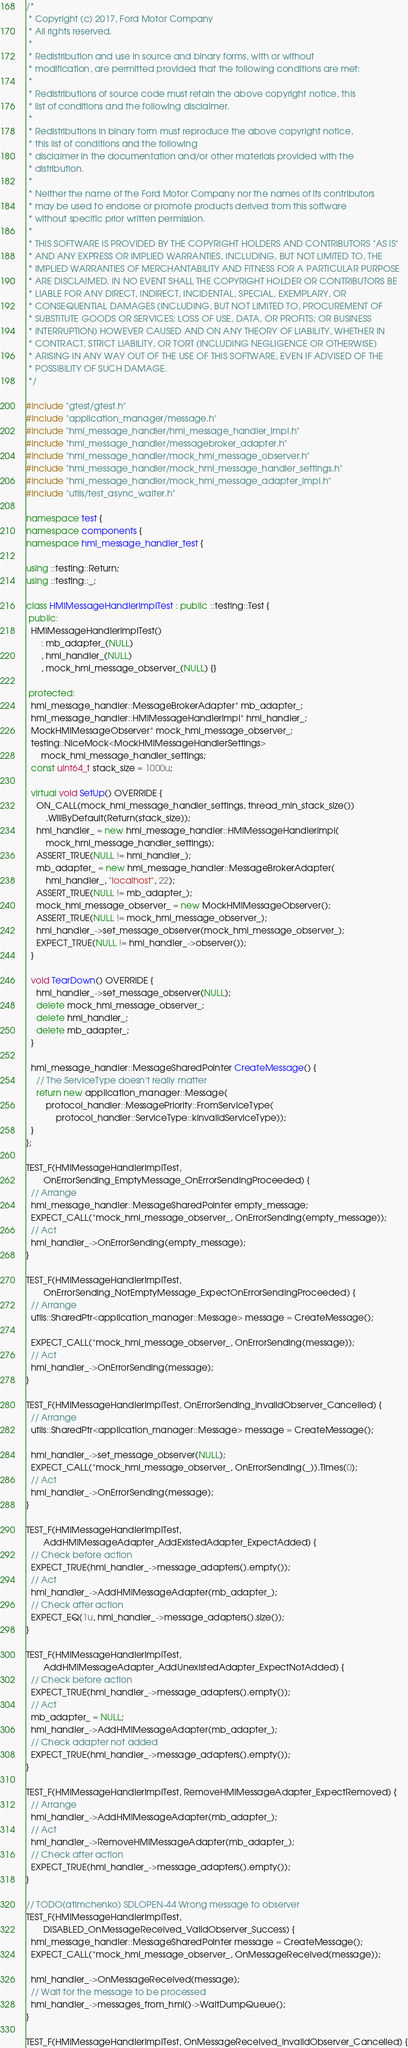Convert code to text. <code><loc_0><loc_0><loc_500><loc_500><_C++_>/*
 * Copyright (c) 2017, Ford Motor Company
 * All rights reserved.
 *
 * Redistribution and use in source and binary forms, with or without
 * modification, are permitted provided that the following conditions are met:
 *
 * Redistributions of source code must retain the above copyright notice, this
 * list of conditions and the following disclaimer.
 *
 * Redistributions in binary form must reproduce the above copyright notice,
 * this list of conditions and the following
 * disclaimer in the documentation and/or other materials provided with the
 * distribution.
 *
 * Neither the name of the Ford Motor Company nor the names of its contributors
 * may be used to endorse or promote products derived from this software
 * without specific prior written permission.
 *
 * THIS SOFTWARE IS PROVIDED BY THE COPYRIGHT HOLDERS AND CONTRIBUTORS "AS IS"
 * AND ANY EXPRESS OR IMPLIED WARRANTIES, INCLUDING, BUT NOT LIMITED TO, THE
 * IMPLIED WARRANTIES OF MERCHANTABILITY AND FITNESS FOR A PARTICULAR PURPOSE
 * ARE DISCLAIMED. IN NO EVENT SHALL THE COPYRIGHT HOLDER OR CONTRIBUTORS BE
 * LIABLE FOR ANY DIRECT, INDIRECT, INCIDENTAL, SPECIAL, EXEMPLARY, OR
 * CONSEQUENTIAL DAMAGES (INCLUDING, BUT NOT LIMITED TO, PROCUREMENT OF
 * SUBSTITUTE GOODS OR SERVICES; LOSS OF USE, DATA, OR PROFITS; OR BUSINESS
 * INTERRUPTION) HOWEVER CAUSED AND ON ANY THEORY OF LIABILITY, WHETHER IN
 * CONTRACT, STRICT LIABILITY, OR TORT (INCLUDING NEGLIGENCE OR OTHERWISE)
 * ARISING IN ANY WAY OUT OF THE USE OF THIS SOFTWARE, EVEN IF ADVISED OF THE
 * POSSIBILITY OF SUCH DAMAGE.
 */

#include "gtest/gtest.h"
#include "application_manager/message.h"
#include "hmi_message_handler/hmi_message_handler_impl.h"
#include "hmi_message_handler/messagebroker_adapter.h"
#include "hmi_message_handler/mock_hmi_message_observer.h"
#include "hmi_message_handler/mock_hmi_message_handler_settings.h"
#include "hmi_message_handler/mock_hmi_message_adapter_impl.h"
#include "utils/test_async_waiter.h"

namespace test {
namespace components {
namespace hmi_message_handler_test {

using ::testing::Return;
using ::testing::_;

class HMIMessageHandlerImplTest : public ::testing::Test {
 public:
  HMIMessageHandlerImplTest()
      : mb_adapter_(NULL)
      , hmi_handler_(NULL)
      , mock_hmi_message_observer_(NULL) {}

 protected:
  hmi_message_handler::MessageBrokerAdapter* mb_adapter_;
  hmi_message_handler::HMIMessageHandlerImpl* hmi_handler_;
  MockHMIMessageObserver* mock_hmi_message_observer_;
  testing::NiceMock<MockHMIMessageHandlerSettings>
      mock_hmi_message_handler_settings;
  const uint64_t stack_size = 1000u;

  virtual void SetUp() OVERRIDE {
    ON_CALL(mock_hmi_message_handler_settings, thread_min_stack_size())
        .WillByDefault(Return(stack_size));
    hmi_handler_ = new hmi_message_handler::HMIMessageHandlerImpl(
        mock_hmi_message_handler_settings);
    ASSERT_TRUE(NULL != hmi_handler_);
    mb_adapter_ = new hmi_message_handler::MessageBrokerAdapter(
        hmi_handler_, "localhost", 22);
    ASSERT_TRUE(NULL != mb_adapter_);
    mock_hmi_message_observer_ = new MockHMIMessageObserver();
    ASSERT_TRUE(NULL != mock_hmi_message_observer_);
    hmi_handler_->set_message_observer(mock_hmi_message_observer_);
    EXPECT_TRUE(NULL != hmi_handler_->observer());
  }

  void TearDown() OVERRIDE {
    hmi_handler_->set_message_observer(NULL);
    delete mock_hmi_message_observer_;
    delete hmi_handler_;
    delete mb_adapter_;
  }

  hmi_message_handler::MessageSharedPointer CreateMessage() {
    // The ServiceType doesn't really matter
    return new application_manager::Message(
        protocol_handler::MessagePriority::FromServiceType(
            protocol_handler::ServiceType::kInvalidServiceType));
  }
};

TEST_F(HMIMessageHandlerImplTest,
       OnErrorSending_EmptyMessage_OnErrorSendingProceeded) {
  // Arrange
  hmi_message_handler::MessageSharedPointer empty_message;
  EXPECT_CALL(*mock_hmi_message_observer_, OnErrorSending(empty_message));
  // Act
  hmi_handler_->OnErrorSending(empty_message);
}

TEST_F(HMIMessageHandlerImplTest,
       OnErrorSending_NotEmptyMessage_ExpectOnErrorSendingProceeded) {
  // Arrange
  utils::SharedPtr<application_manager::Message> message = CreateMessage();

  EXPECT_CALL(*mock_hmi_message_observer_, OnErrorSending(message));
  // Act
  hmi_handler_->OnErrorSending(message);
}

TEST_F(HMIMessageHandlerImplTest, OnErrorSending_InvalidObserver_Cancelled) {
  // Arrange
  utils::SharedPtr<application_manager::Message> message = CreateMessage();

  hmi_handler_->set_message_observer(NULL);
  EXPECT_CALL(*mock_hmi_message_observer_, OnErrorSending(_)).Times(0);
  // Act
  hmi_handler_->OnErrorSending(message);
}

TEST_F(HMIMessageHandlerImplTest,
       AddHMIMessageAdapter_AddExistedAdapter_ExpectAdded) {
  // Check before action
  EXPECT_TRUE(hmi_handler_->message_adapters().empty());
  // Act
  hmi_handler_->AddHMIMessageAdapter(mb_adapter_);
  // Check after action
  EXPECT_EQ(1u, hmi_handler_->message_adapters().size());
}

TEST_F(HMIMessageHandlerImplTest,
       AddHMIMessageAdapter_AddUnexistedAdapter_ExpectNotAdded) {
  // Check before action
  EXPECT_TRUE(hmi_handler_->message_adapters().empty());
  // Act
  mb_adapter_ = NULL;
  hmi_handler_->AddHMIMessageAdapter(mb_adapter_);
  // Check adapter not added
  EXPECT_TRUE(hmi_handler_->message_adapters().empty());
}

TEST_F(HMIMessageHandlerImplTest, RemoveHMIMessageAdapter_ExpectRemoved) {
  // Arrange
  hmi_handler_->AddHMIMessageAdapter(mb_adapter_);
  // Act
  hmi_handler_->RemoveHMIMessageAdapter(mb_adapter_);
  // Check after action
  EXPECT_TRUE(hmi_handler_->message_adapters().empty());
}

// TODO(atimchenko) SDLOPEN-44 Wrong message to observer
TEST_F(HMIMessageHandlerImplTest,
       DISABLED_OnMessageReceived_ValidObserver_Success) {
  hmi_message_handler::MessageSharedPointer message = CreateMessage();
  EXPECT_CALL(*mock_hmi_message_observer_, OnMessageReceived(message));

  hmi_handler_->OnMessageReceived(message);
  // Wait for the message to be processed
  hmi_handler_->messages_from_hmi()->WaitDumpQueue();
}

TEST_F(HMIMessageHandlerImplTest, OnMessageReceived_InvalidObserver_Cancelled) {</code> 